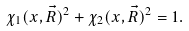Convert formula to latex. <formula><loc_0><loc_0><loc_500><loc_500>\chi _ { 1 } ( x , \vec { R } ) ^ { 2 } + \chi _ { 2 } ( x , \vec { R } ) ^ { 2 } = 1 .</formula> 